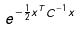Convert formula to latex. <formula><loc_0><loc_0><loc_500><loc_500>e ^ { - \frac { 1 } { 2 } x ^ { T } C ^ { - 1 } x }</formula> 